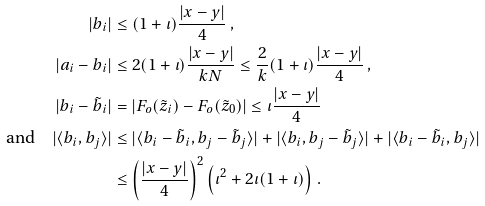<formula> <loc_0><loc_0><loc_500><loc_500>| b _ { i } | & \leq ( 1 + \iota ) \frac { | x - y | } { 4 } \, , \\ | a _ { i } - b _ { i } | & \leq 2 ( 1 + \iota ) \frac { | x - y | } { k N } \leq \frac { 2 } { k } ( 1 + \iota ) \frac { | x - y | } { 4 } \, , \\ | b _ { i } - \tilde { b } _ { i } | & = | F _ { o } ( \tilde { z } _ { i } ) - F _ { o } ( \tilde { z } _ { 0 } ) | \leq \iota \frac { | x - y | } { 4 } \\ \text {and} \quad | \langle b _ { i } , b _ { j } \rangle | & \leq | \langle b _ { i } - \tilde { b } _ { i } , b _ { j } - \tilde { b } _ { j } \rangle | + | \langle b _ { i } , b _ { j } - \tilde { b } _ { j } \rangle | + | \langle b _ { i } - \tilde { b } _ { i } , b _ { j } \rangle | \\ & \leq \left ( \frac { | x - y | } { 4 } \right ) ^ { 2 } \left ( \iota ^ { 2 } + 2 \iota ( 1 + \iota ) \right ) \, .</formula> 